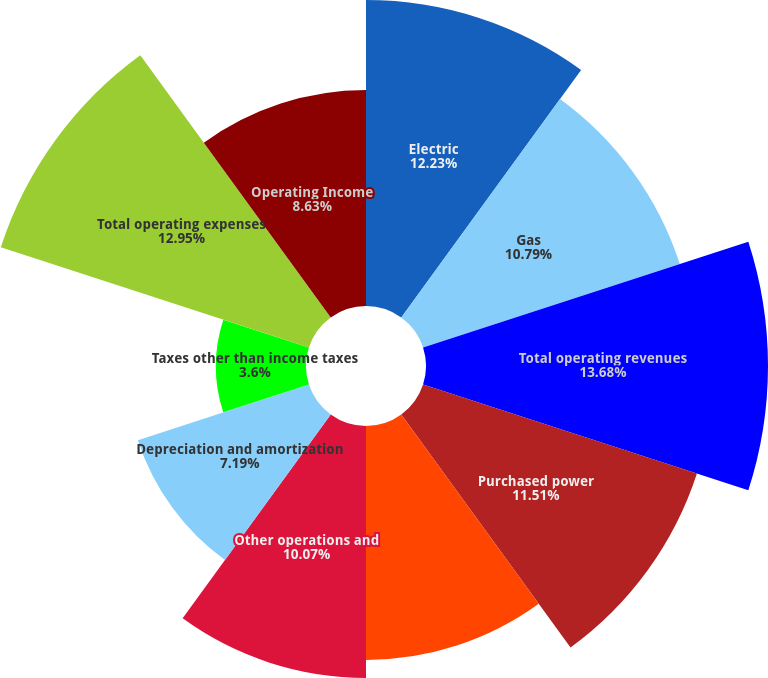Convert chart. <chart><loc_0><loc_0><loc_500><loc_500><pie_chart><fcel>Electric<fcel>Gas<fcel>Total operating revenues<fcel>Purchased power<fcel>Gas purchased for resale<fcel>Other operations and<fcel>Depreciation and amortization<fcel>Taxes other than income taxes<fcel>Total operating expenses<fcel>Operating Income<nl><fcel>12.23%<fcel>10.79%<fcel>13.67%<fcel>11.51%<fcel>9.35%<fcel>10.07%<fcel>7.19%<fcel>3.6%<fcel>12.95%<fcel>8.63%<nl></chart> 